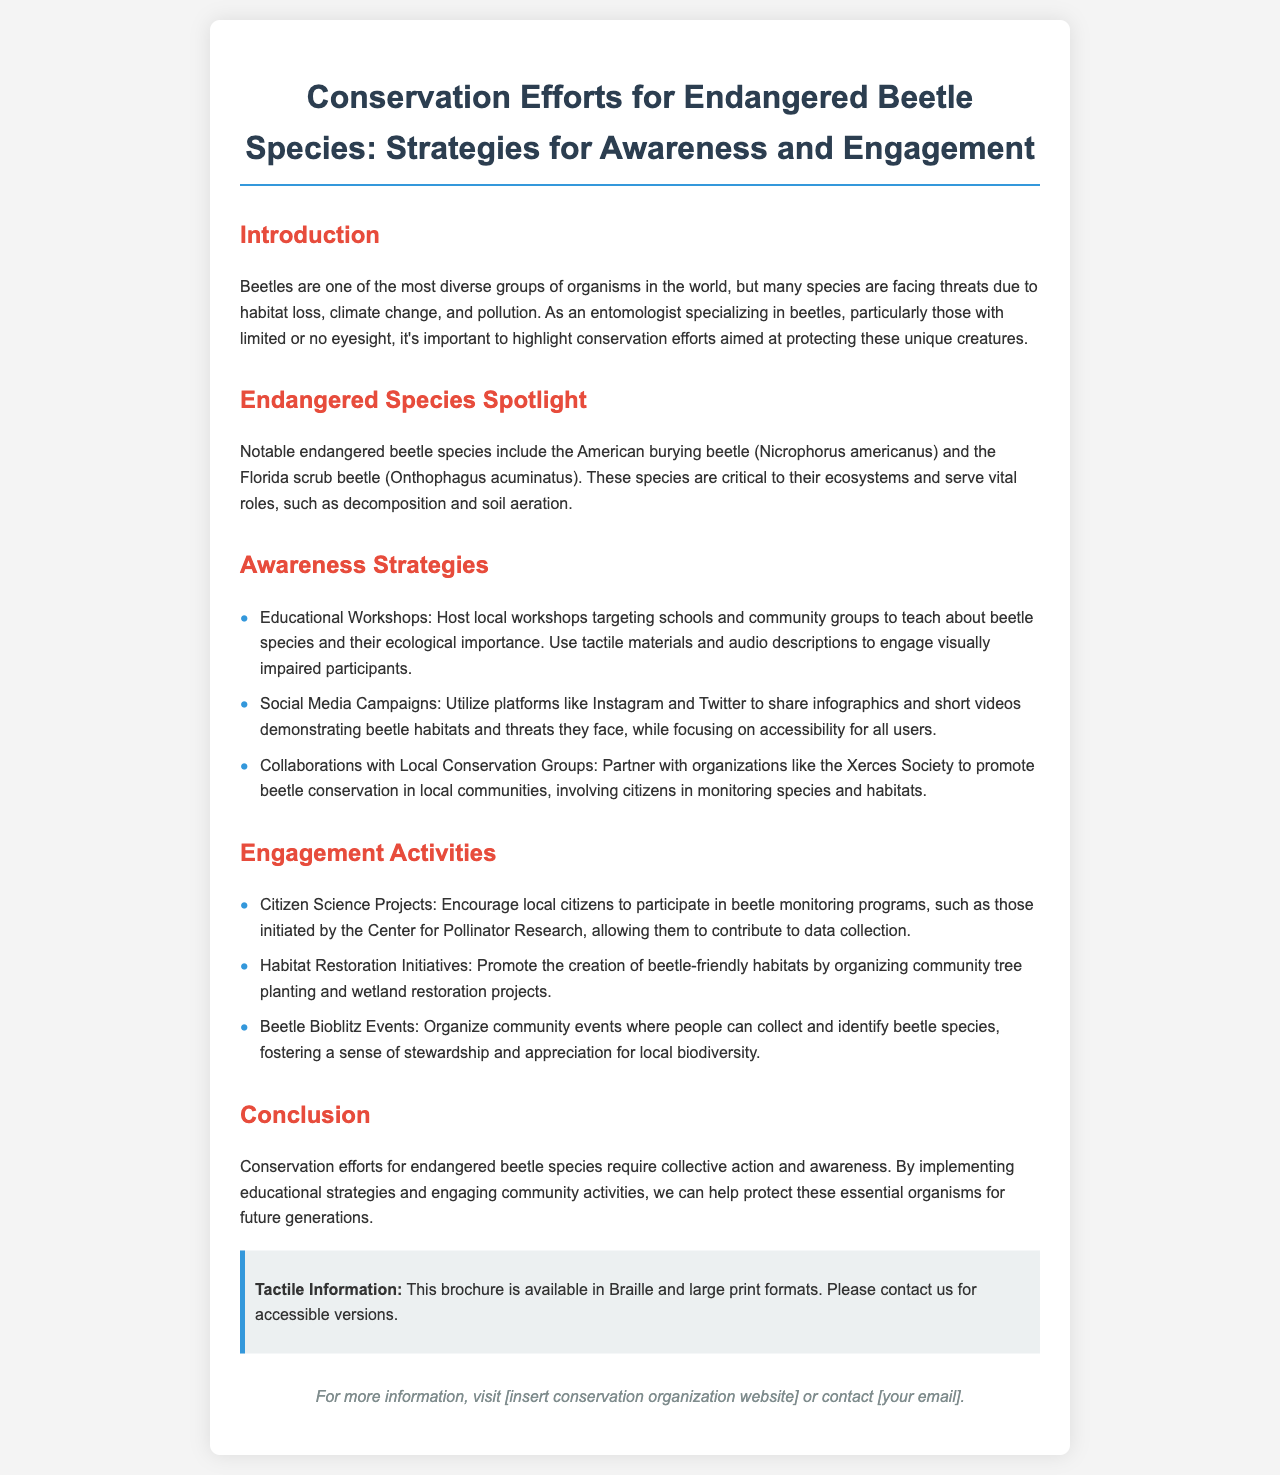What is the main topic of the brochure? The brochure discusses conservation efforts for endangered beetle species, particularly focusing on strategies for awareness and engagement.
Answer: Conservation Efforts for Endangered Beetle Species Which two beetle species are highlighted as endangered? The document specifically mentions the American burying beetle and the Florida scrub beetle as notable endangered species.
Answer: American burying beetle and Florida scrub beetle What type of workshops does the brochure suggest for raising awareness? The brochure suggests hosting educational workshops targeting schools and community groups to teach about beetle species and their ecological importance.
Answer: Educational Workshops Who can citizens partner with for conservation? Citizens are encouraged to collaborate with local conservation groups such as the Xerces Society to promote beetle conservation.
Answer: Xerces Society What initiative encourages local citizens to participate in beetle monitoring? The brochure mentions citizen science projects as a way for local citizens to engage in beetle monitoring programs, allowing for data collection.
Answer: Citizen Science Projects What tactile resources are mentioned in the brochure? The brochure offers information that it is available in Braille and large print formats for accessibility purposes.
Answer: Braille and large print formats What is one of the suggested engagement activities listed in the brochure? The document lists organizing community Beetle Bioblitz events as a way to engage people and foster appreciation for local biodiversity.
Answer: Beetle Bioblitz Events What ecological role do the highlighted beetle species serve? The highlighted beetle species serve vital roles such as decomposition and soil aeration within their ecosystems.
Answer: Decomposition and soil aeration 